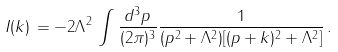<formula> <loc_0><loc_0><loc_500><loc_500>I ( k ) \, = - 2 \Lambda ^ { 2 } \, \int \frac { d ^ { 3 } p } { ( 2 \pi ) ^ { 3 } } \frac { 1 } { ( p ^ { 2 } + \Lambda ^ { 2 } ) [ ( p + k ) ^ { 2 } + \Lambda ^ { 2 } ] } \, .</formula> 